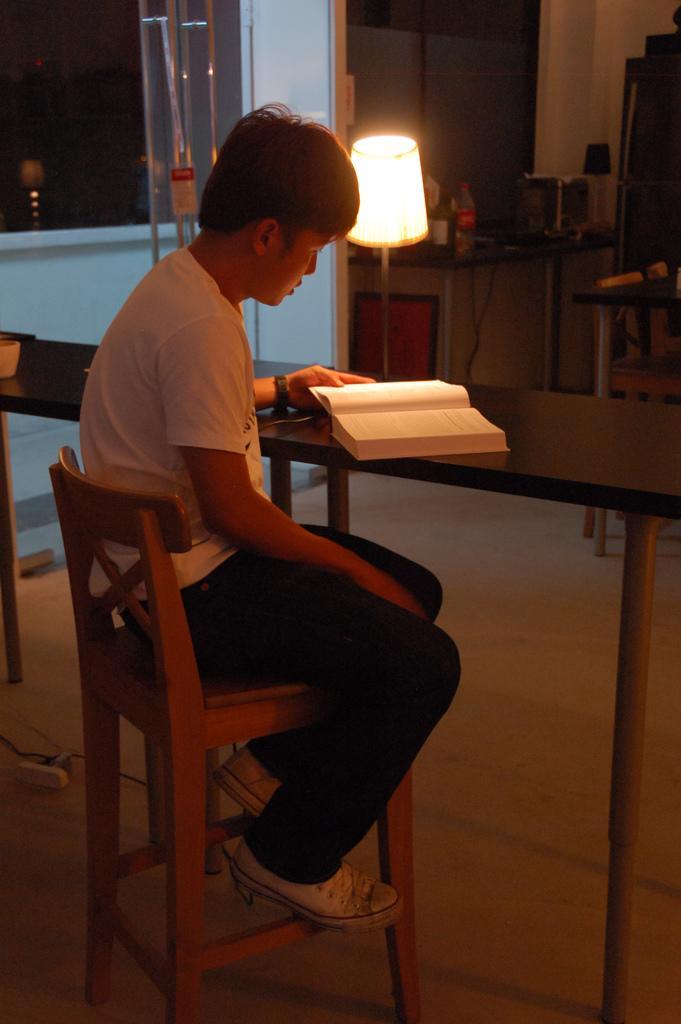Could you give a brief overview of what you see in this image? As we can see in the image there is a window, lamp, table and on table there is a book and a boy sitting on chair. 